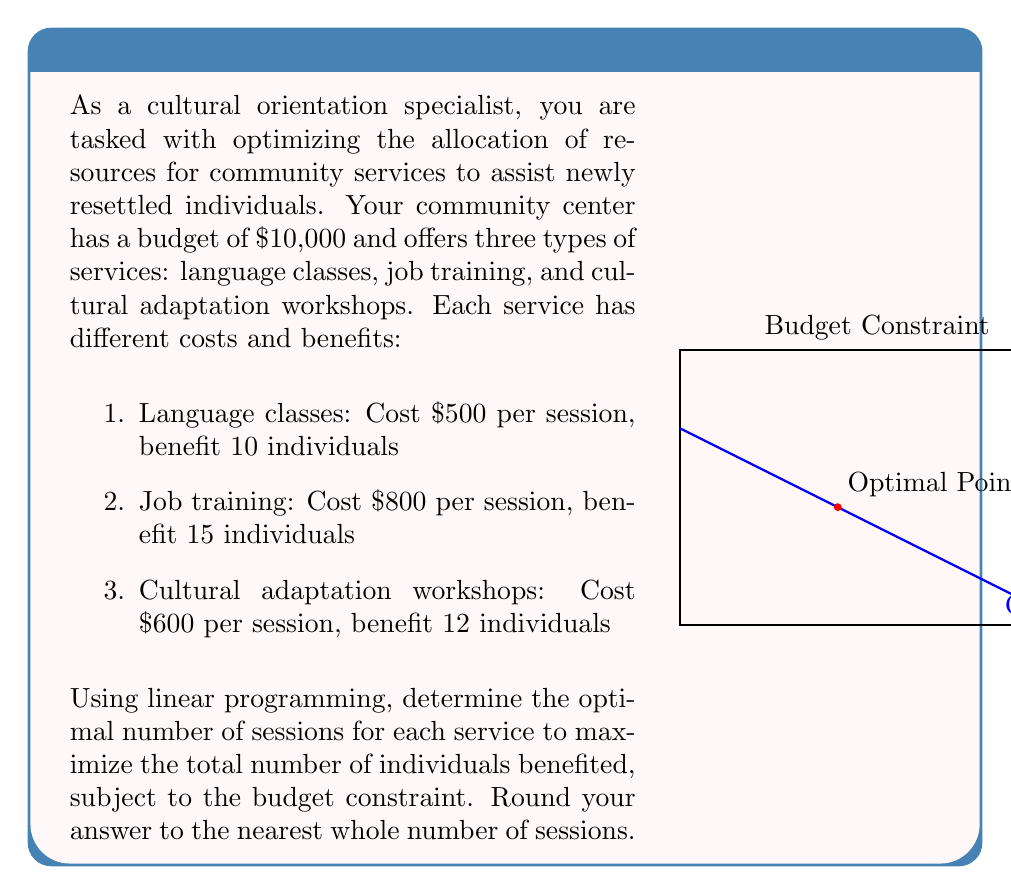Show me your answer to this math problem. Let's approach this step-by-step using linear programming:

1) Define variables:
   Let $x$ = number of language class sessions
   Let $y$ = number of job training sessions
   Let $z$ = number of cultural adaptation workshop sessions

2) Objective function:
   Maximize $f(x,y,z) = 10x + 15y + 12z$ (total individuals benefited)

3) Constraints:
   Budget constraint: $500x + 800y + 600z \leq 10000$
   Non-negativity: $x \geq 0$, $y \geq 0$, $z \geq 0$

4) Set up the linear programming problem:
   
   Maximize $f(x,y,z) = 10x + 15y + 12z$
   Subject to:
   $500x + 800y + 600z \leq 10000$
   $x, y, z \geq 0$

5) Solve using the simplex method or a linear programming solver. The optimal solution is:

   $x \approx 8$, $y \approx 6.25$, $z \approx 0$

6) Rounding to the nearest whole number of sessions:
   Language classes: 8 sessions
   Job training: 6 sessions
   Cultural adaptation workshops: 0 sessions

7) Verify the solution:
   Budget used: $500(8) + 800(6) + 600(0) = 8800 \leq 10000$
   Total individuals benefited: $10(8) + 15(6) + 12(0) = 170$

This solution maximizes the number of individuals benefited while staying within the budget constraint.
Answer: 8 language class sessions, 6 job training sessions, 0 cultural adaptation workshops 